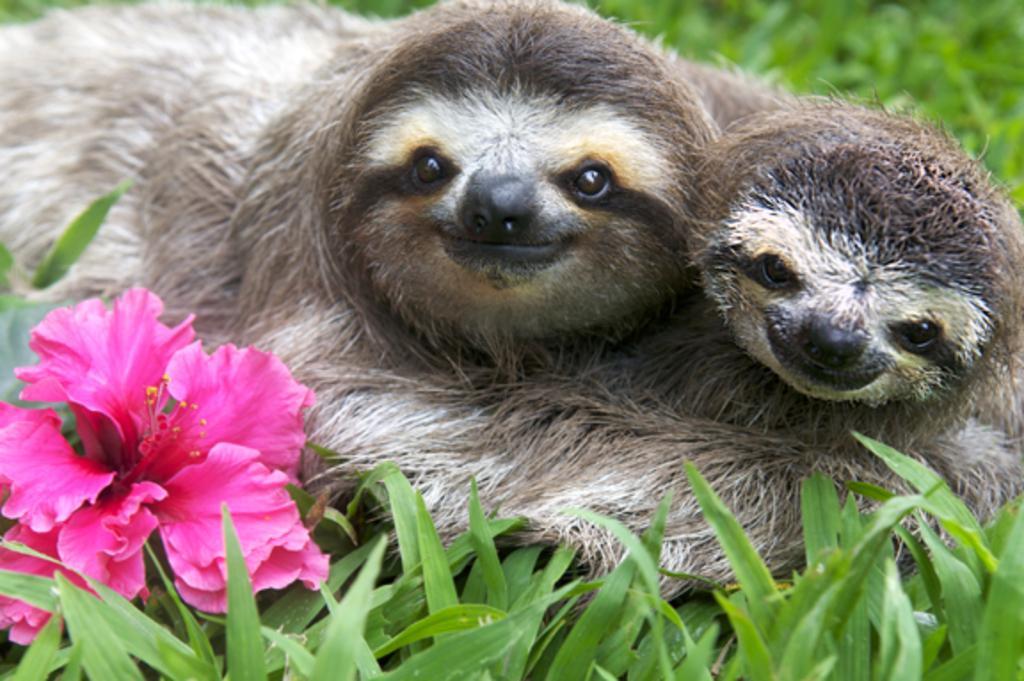Describe this image in one or two sentences. In this image we can see two animals on the ground, one flower, one green object looks like leaf behind the flower, some grass on the ground and the background is blurred. 